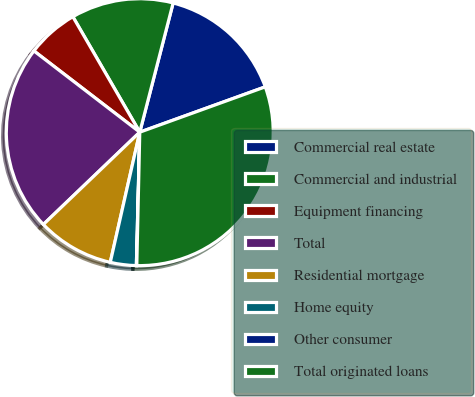Convert chart. <chart><loc_0><loc_0><loc_500><loc_500><pie_chart><fcel>Commercial real estate<fcel>Commercial and industrial<fcel>Equipment financing<fcel>Total<fcel>Residential mortgage<fcel>Home equity<fcel>Other consumer<fcel>Total originated loans<nl><fcel>15.46%<fcel>12.38%<fcel>6.22%<fcel>22.57%<fcel>9.3%<fcel>3.14%<fcel>0.05%<fcel>30.87%<nl></chart> 